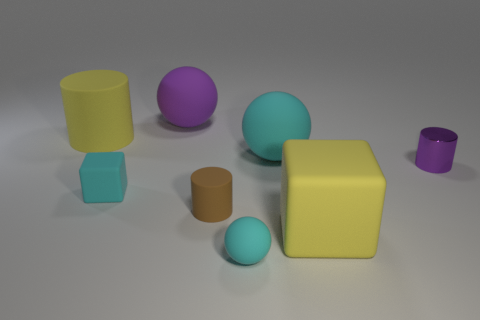Subtract all small cyan matte spheres. How many spheres are left? 2 Add 2 cyan matte balls. How many objects exist? 10 Subtract all blocks. How many objects are left? 6 Subtract all large things. Subtract all cylinders. How many objects are left? 1 Add 6 tiny cyan matte things. How many tiny cyan matte things are left? 8 Add 3 large yellow things. How many large yellow things exist? 5 Subtract 1 purple spheres. How many objects are left? 7 